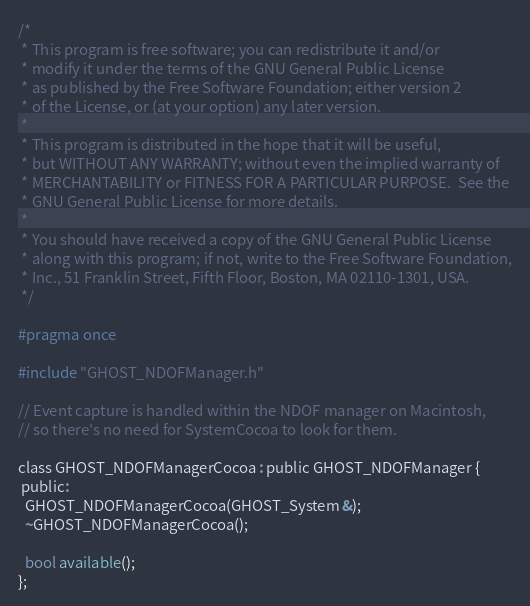Convert code to text. <code><loc_0><loc_0><loc_500><loc_500><_C_>/*
 * This program is free software; you can redistribute it and/or
 * modify it under the terms of the GNU General Public License
 * as published by the Free Software Foundation; either version 2
 * of the License, or (at your option) any later version.
 *
 * This program is distributed in the hope that it will be useful,
 * but WITHOUT ANY WARRANTY; without even the implied warranty of
 * MERCHANTABILITY or FITNESS FOR A PARTICULAR PURPOSE.  See the
 * GNU General Public License for more details.
 *
 * You should have received a copy of the GNU General Public License
 * along with this program; if not, write to the Free Software Foundation,
 * Inc., 51 Franklin Street, Fifth Floor, Boston, MA 02110-1301, USA.
 */

#pragma once

#include "GHOST_NDOFManager.h"

// Event capture is handled within the NDOF manager on Macintosh,
// so there's no need for SystemCocoa to look for them.

class GHOST_NDOFManagerCocoa : public GHOST_NDOFManager {
 public:
  GHOST_NDOFManagerCocoa(GHOST_System &);
  ~GHOST_NDOFManagerCocoa();

  bool available();
};
</code> 